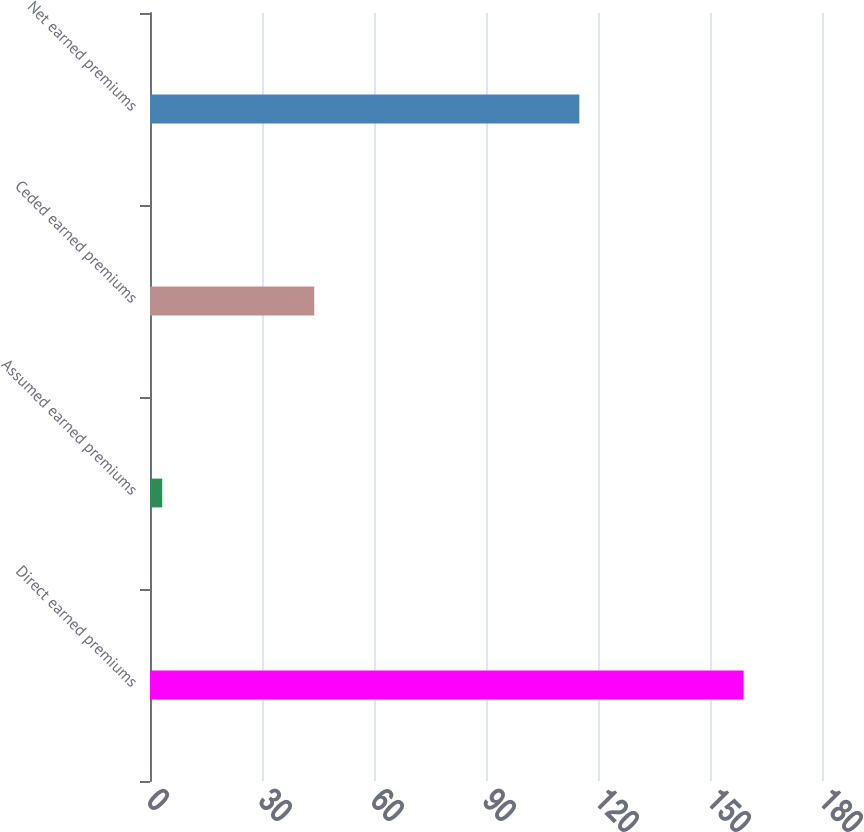<chart> <loc_0><loc_0><loc_500><loc_500><bar_chart><fcel>Direct earned premiums<fcel>Assumed earned premiums<fcel>Ceded earned premiums<fcel>Net earned premiums<nl><fcel>159<fcel>3.27<fcel>44<fcel>115<nl></chart> 